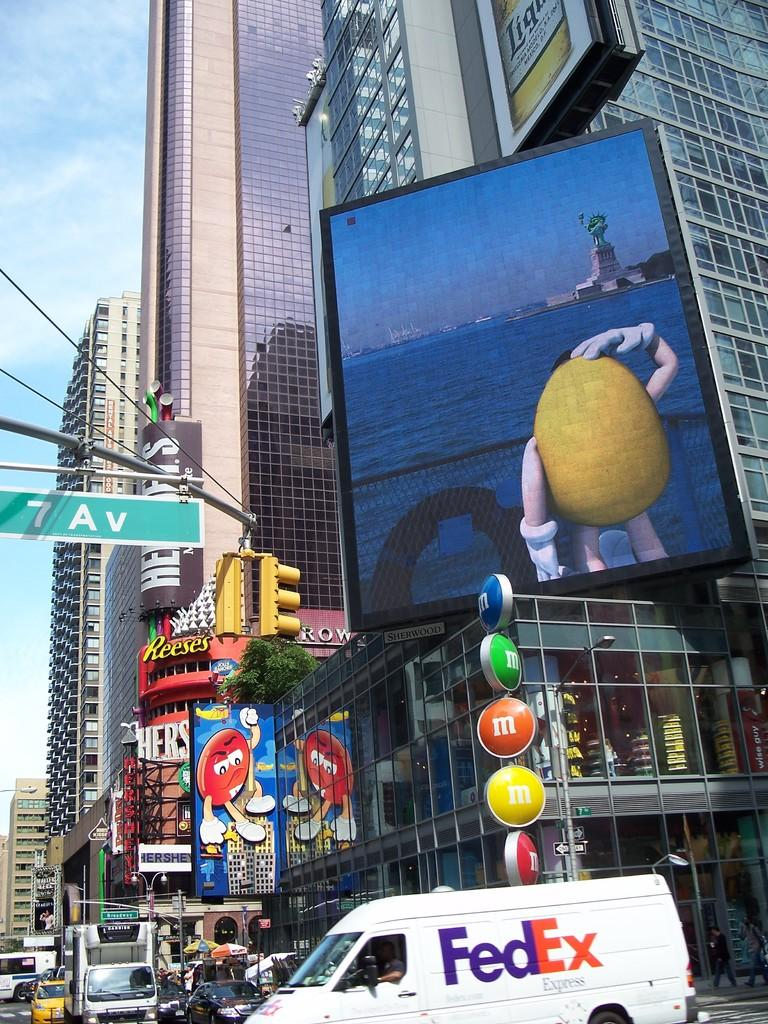<image>
Create a compact narrative representing the image presented. a sign that says 7 av at the top of it 